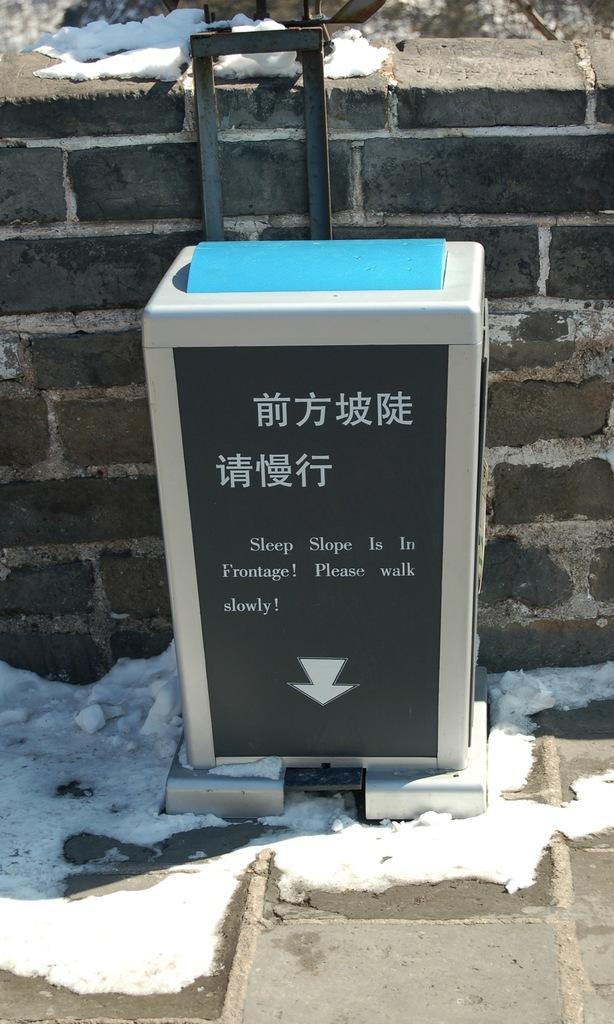Should you walk slowly or fast by this?
Your answer should be very brief. Slowly. What is the first english word on this sign?
Provide a succinct answer. Sleep. 